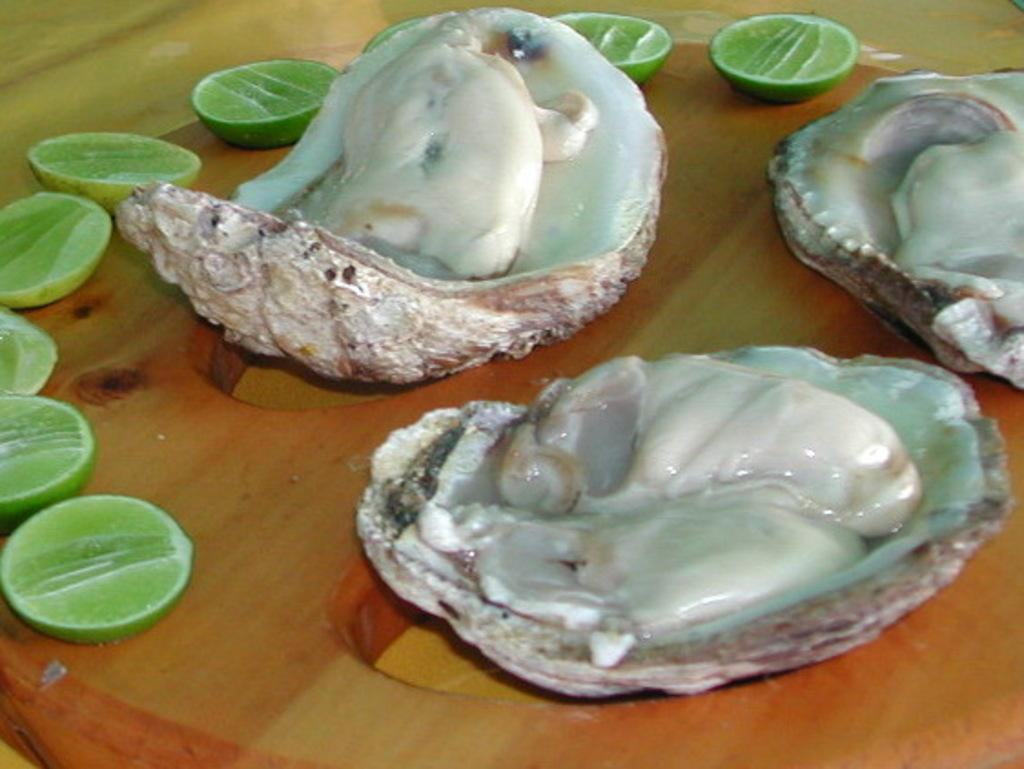What is present on the table in the image? There is food on the table in the image. Can you identify any specific ingredients or items in the food? Yes, there are lemon pieces in the image. How many houses can be seen in the image? There are no houses present in the image; it features food on a table with lemon pieces. What type of ladybug is crawling on the lemon in the image? There is no ladybug present in the image; it only shows food on a table with lemon pieces. 